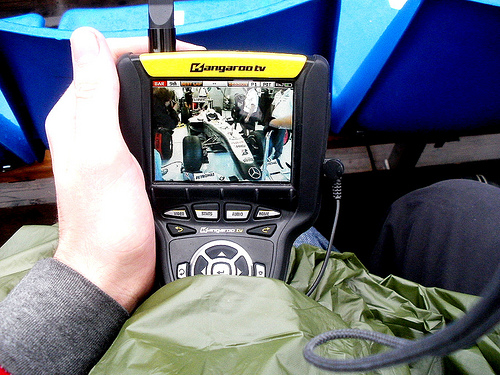<image>
Can you confirm if the screen is on the skin? No. The screen is not positioned on the skin. They may be near each other, but the screen is not supported by or resting on top of the skin. 